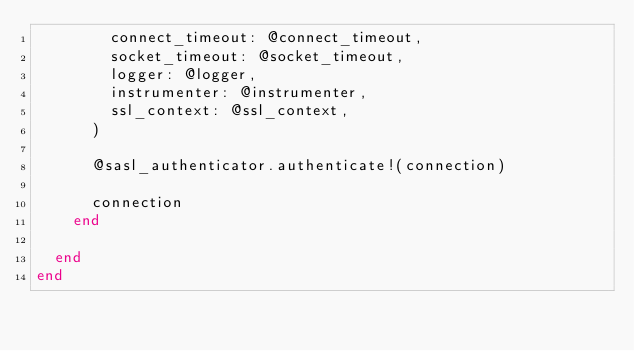Convert code to text. <code><loc_0><loc_0><loc_500><loc_500><_Ruby_>        connect_timeout: @connect_timeout,
        socket_timeout: @socket_timeout,
        logger: @logger,
        instrumenter: @instrumenter,
        ssl_context: @ssl_context,
      )

      @sasl_authenticator.authenticate!(connection)

      connection
    end

  end
end
</code> 